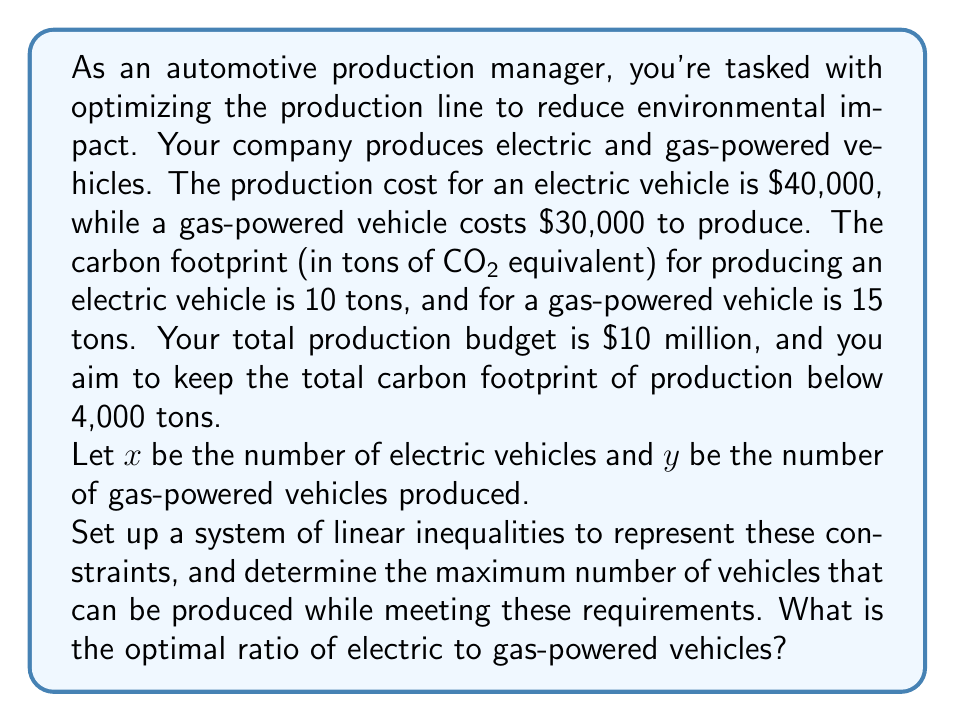Can you solve this math problem? Let's approach this step-by-step:

1) First, let's set up our constraints:

   Budget constraint: $40000x + 30000y \leq 10000000$
   Carbon footprint constraint: $10x + 15y \leq 4000$

2) Simplify the budget constraint:
   $4x + 3y \leq 1000$

3) Now we have a system of linear inequalities:
   $$\begin{cases}
   4x + 3y \leq 1000 \\
   10x + 15y \leq 4000 \\
   x \geq 0, y \geq 0
   \end{cases}$$

4) To maximize the number of vehicles, we need to maximize $x + y$.

5) We can solve this using the corner point method. The corner points are where these lines intersect each other and the axes.

6) Solving the system of equations:
   $4x + 3y = 1000$ and $10x + 15y = 4000$

   Multiplying the first equation by 5 and the second by -2:
   $20x + 15y = 5000$
   $-20x - 30y = -8000$
   
   Adding these equations:
   $-15y = -3000$
   $y = 200$

   Substituting back:
   $4x + 3(200) = 1000$
   $4x = 400$
   $x = 100$

7) The corner point (100, 200) gives the maximum number of vehicles: 300.

8) The ratio of electric to gas-powered vehicles is 100:200, which simplifies to 1:2.
Answer: The optimal production plan is to produce 100 electric vehicles and 200 gas-powered vehicles, for a total of 300 vehicles. The optimal ratio of electric to gas-powered vehicles is 1:2. 